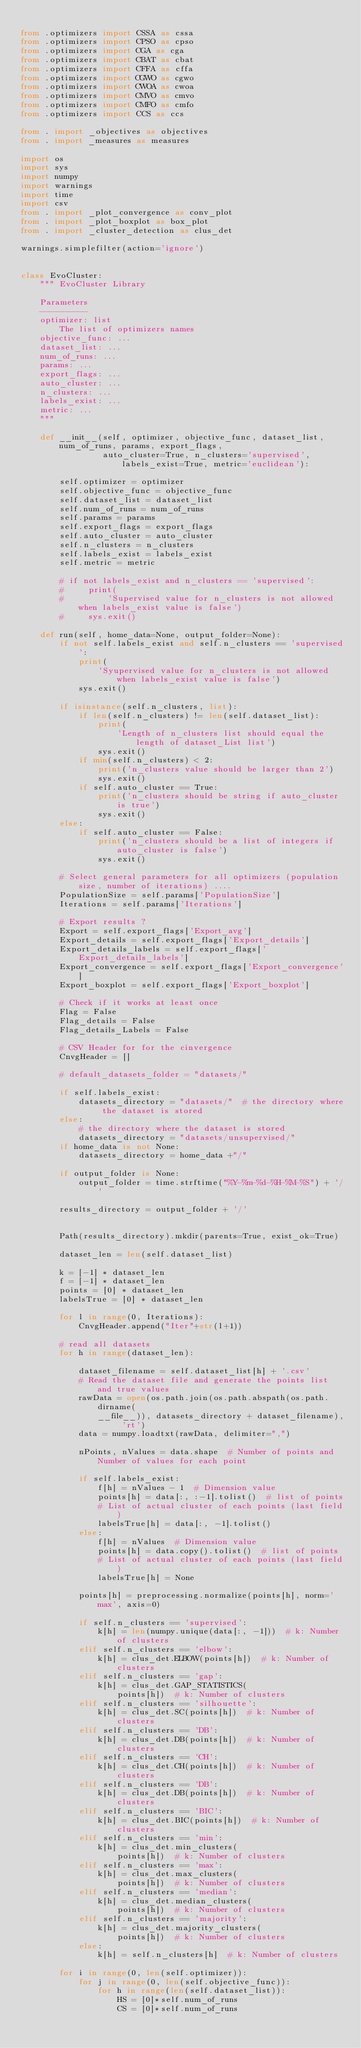Convert code to text. <code><loc_0><loc_0><loc_500><loc_500><_Python_>
from .optimizers import CSSA as cssa
from .optimizers import CPSO as cpso
from .optimizers import CGA as cga
from .optimizers import CBAT as cbat
from .optimizers import CFFA as cffa
from .optimizers import CGWO as cgwo
from .optimizers import CWOA as cwoa
from .optimizers import CMVO as cmvo
from .optimizers import CMFO as cmfo
from .optimizers import CCS as ccs

from . import _objectives as objectives
from . import _measures as measures

import os
import sys
import numpy
import warnings
import time
import csv
from . import _plot_convergence as conv_plot
from . import _plot_boxplot as box_plot
from . import _cluster_detection as clus_det

warnings.simplefilter(action='ignore')


class EvoCluster:
    """ EvoCluster Library

    Parameters
    ----------
    optimizer: list
        The list of optimizers names
    objective_func: ...
    dataset_list: ...
    num_of_runs: ...
    params: ...
    export_flags: ...
    auto_cluster: ...
    n_clusters: ...
    labels_exist: ...
    metric: ...
    """

    def __init__(self, optimizer, objective_func, dataset_list, num_of_runs, params, export_flags,
                 auto_cluster=True, n_clusters='supervised', labels_exist=True, metric='euclidean'):

        self.optimizer = optimizer
        self.objective_func = objective_func
        self.dataset_list = dataset_list
        self.num_of_runs = num_of_runs
        self.params = params
        self.export_flags = export_flags
        self.auto_cluster = auto_cluster
        self.n_clusters = n_clusters
        self.labels_exist = labels_exist
        self.metric = metric

        # if not labels_exist and n_clusters == 'supervised':
        #     print(
        #         'Supervised value for n_clusters is not allowed when labels_exist value is false')
        #     sys.exit()

    def run(self, home_data=None, output_folder=None):
        if not self.labels_exist and self.n_clusters == 'supervised':
            print(
                'Syupervised value for n_clusters is not allowed when labels_exist value is false')
            sys.exit()

        if isinstance(self.n_clusters, list):
            if len(self.n_clusters) != len(self.dataset_list):
                print(
                    'Length of n_clusters list should equal the length of dataset_List list')
                sys.exit()
            if min(self.n_clusters) < 2:
                print('n_clusters value should be larger than 2')
                sys.exit()
            if self.auto_cluster == True:
                print('n_clusters should be string if auto_cluster is true')
                sys.exit()
        else:
            if self.auto_cluster == False:
                print('n_clusters should be a list of integers if auto_cluster is false')
                sys.exit()

        # Select general parameters for all optimizers (population size, number of iterations) ....
        PopulationSize = self.params['PopulationSize']
        Iterations = self.params['Iterations']

        # Export results ?
        Export = self.export_flags['Export_avg']
        Export_details = self.export_flags['Export_details']
        Export_details_labels = self.export_flags['Export_details_labels']
        Export_convergence = self.export_flags['Export_convergence']
        Export_boxplot = self.export_flags['Export_boxplot']

        # Check if it works at least once
        Flag = False
        Flag_details = False
        Flag_details_Labels = False

        # CSV Header for for the cinvergence
        CnvgHeader = []

        # default_datasets_folder = "datasets/"

        if self.labels_exist:
            datasets_directory = "datasets/"  # the directory where the dataset is stored
        else:
            # the directory where the dataset is stored
            datasets_directory = "datasets/unsupervised/"
        if home_data is not None:
            datasets_directory = home_data +"/"

        if output_folder is None:
            output_folder = time.strftime("%Y-%m-%d-%H-%M-%S") + '/'
            
        results_directory = output_folder + '/'

        
        Path(results_directory).mkdir(parents=True, exist_ok=True)

        dataset_len = len(self.dataset_list)

        k = [-1] * dataset_len
        f = [-1] * dataset_len
        points = [0] * dataset_len
        labelsTrue = [0] * dataset_len

        for l in range(0, Iterations):
            CnvgHeader.append("Iter"+str(l+1))

        # read all datasets
        for h in range(dataset_len):

            dataset_filename = self.dataset_list[h] + '.csv'
            # Read the dataset file and generate the points list and true values
            rawData = open(os.path.join(os.path.abspath(os.path.dirname(
                __file__)), datasets_directory + dataset_filename), 'rt')
            data = numpy.loadtxt(rawData, delimiter=",")

            nPoints, nValues = data.shape  # Number of points and Number of values for each point

            if self.labels_exist:
                f[h] = nValues - 1  # Dimension value
                points[h] = data[:, :-1].tolist()  # list of points
                # List of actual cluster of each points (last field)
                labelsTrue[h] = data[:, -1].tolist()
            else:
                f[h] = nValues  # Dimension value
                points[h] = data.copy().tolist()  # list of points
                # List of actual cluster of each points (last field)
                labelsTrue[h] = None

            points[h] = preprocessing.normalize(points[h], norm='max', axis=0)

            if self.n_clusters == 'supervised':
                k[h] = len(numpy.unique(data[:, -1]))  # k: Number of clusters
            elif self.n_clusters == 'elbow':
                k[h] = clus_det.ELBOW(points[h])  # k: Number of clusters
            elif self.n_clusters == 'gap':
                k[h] = clus_det.GAP_STATISTICS(
                    points[h])  # k: Number of clusters
            elif self.n_clusters == 'silhouette':
                k[h] = clus_det.SC(points[h])  # k: Number of clusters
            elif self.n_clusters == 'DB':
                k[h] = clus_det.DB(points[h])  # k: Number of clusters
            elif self.n_clusters == 'CH':
                k[h] = clus_det.CH(points[h])  # k: Number of clusters
            elif self.n_clusters == 'DB':
                k[h] = clus_det.DB(points[h])  # k: Number of clusters
            elif self.n_clusters == 'BIC':
                k[h] = clus_det.BIC(points[h])  # k: Number of clusters
            elif self.n_clusters == 'min':
                k[h] = clus_det.min_clusters(
                    points[h])  # k: Number of clusters
            elif self.n_clusters == 'max':
                k[h] = clus_det.max_clusters(
                    points[h])  # k: Number of clusters
            elif self.n_clusters == 'median':
                k[h] = clus_det.median_clusters(
                    points[h])  # k: Number of clusters
            elif self.n_clusters == 'majority':
                k[h] = clus_det.majority_clusters(
                    points[h])  # k: Number of clusters
            else:
                k[h] = self.n_clusters[h]  # k: Number of clusters

        for i in range(0, len(self.optimizer)):
            for j in range(0, len(self.objective_func)):
                for h in range(len(self.dataset_list)):
                    HS = [0]*self.num_of_runs
                    CS = [0]*self.num_of_runs</code> 